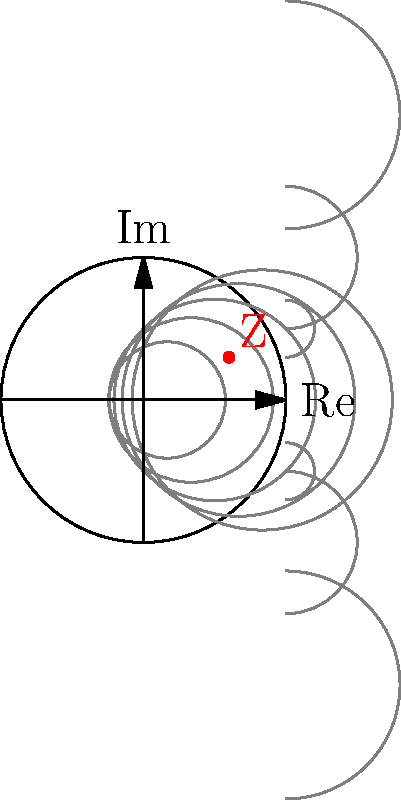In the Smith chart shown above, a load impedance Z is marked. What is the approximate normalized impedance value of Z, and what type of matching network would be most suitable to match this load to a 50Ω source? To interpret the Smith chart and determine the appropriate matching network, we'll follow these steps:

1. Locate the point Z on the Smith chart.
2. Estimate the normalized resistance (real part):
   - The point is slightly to the right of the 0.5 resistance circle.
   - Estimated normalized resistance ≈ 0.6

3. Estimate the normalized reactance (imaginary part):
   - The point is above the horizontal axis, indicating positive reactance.
   - It's between the 0.5 and 1 reactance arcs.
   - Estimated normalized reactance ≈ 0.3

4. Combine the estimates:
   Normalized impedance ≈ 0.6 + j0.3

5. To denormalize (assuming 50Ω reference impedance):
   Z ≈ (0.6 + j0.3) * 50Ω ≈ 30Ω + j15Ω

6. Determine the matching network:
   - The load impedance has both resistive and reactive components.
   - It needs to be transformed to 50Ω (1 + j0 on the normalized Smith chart).
   - An L-network would be suitable for this transformation.
   - Since the resistance needs to be increased and there's already positive reactance, a series inductor and shunt capacitor configuration would be most appropriate.

Therefore, the most suitable matching network would be an L-network with a series inductor and a shunt capacitor.
Answer: Normalized impedance ≈ 0.6 + j0.3; L-network with series inductor and shunt capacitor 